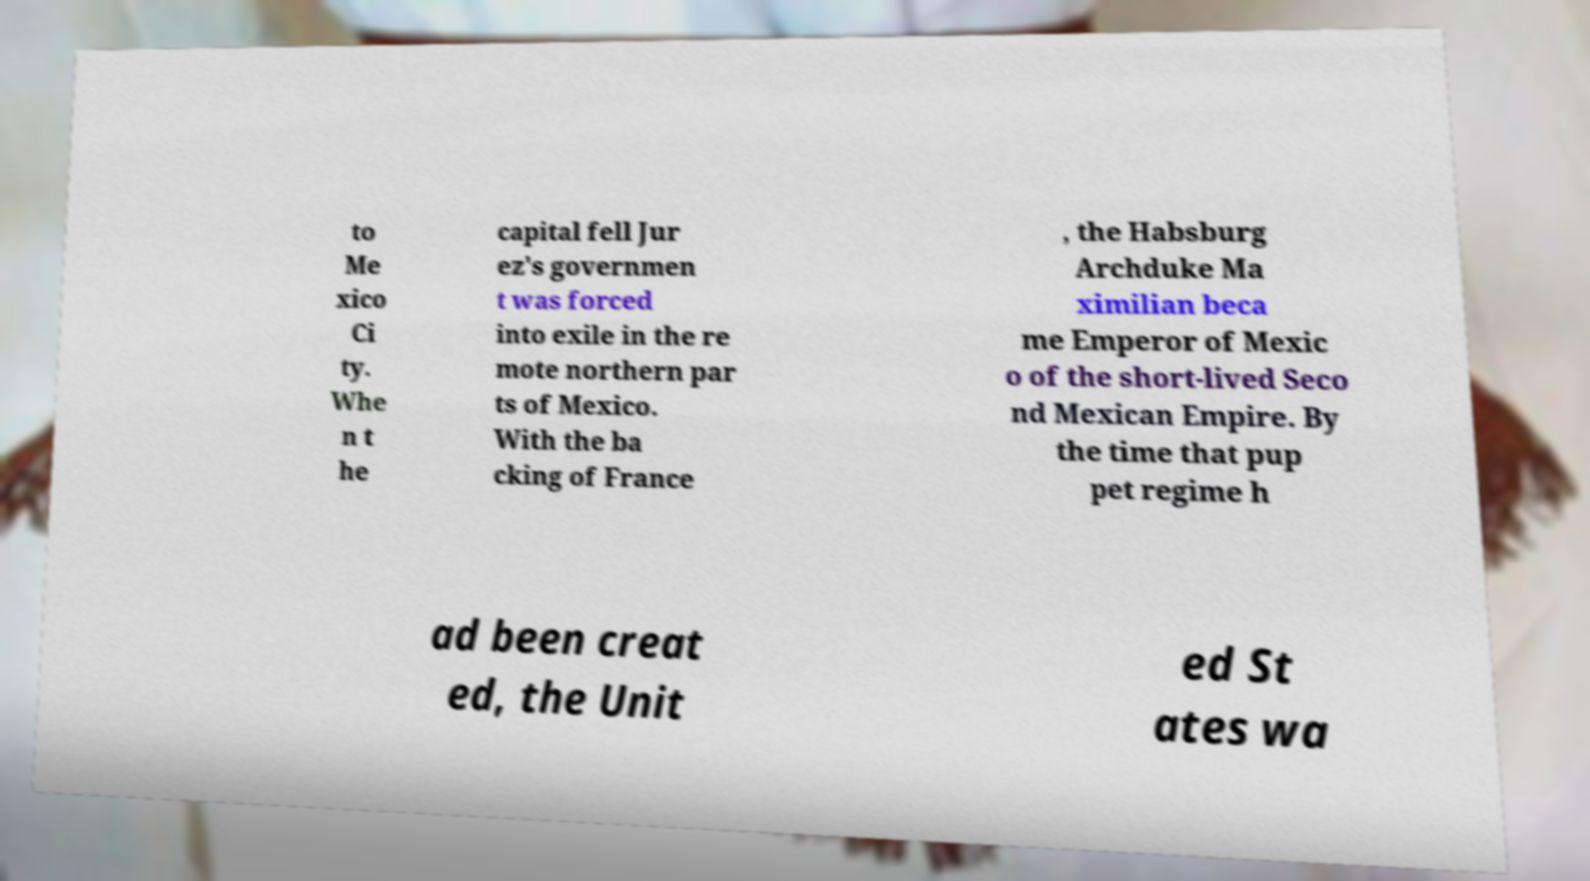There's text embedded in this image that I need extracted. Can you transcribe it verbatim? to Me xico Ci ty. Whe n t he capital fell Jur ez's governmen t was forced into exile in the re mote northern par ts of Mexico. With the ba cking of France , the Habsburg Archduke Ma ximilian beca me Emperor of Mexic o of the short-lived Seco nd Mexican Empire. By the time that pup pet regime h ad been creat ed, the Unit ed St ates wa 